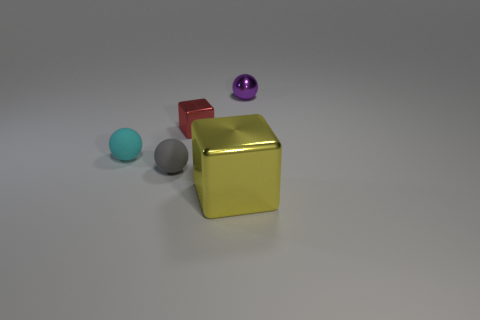Does the purple metal ball have the same size as the gray sphere?
Provide a succinct answer. Yes. There is a red metallic object; does it have the same size as the cyan rubber ball that is to the left of the gray thing?
Your answer should be very brief. Yes. The metallic thing that is behind the big cube and in front of the tiny metallic ball is what color?
Provide a short and direct response. Red. Are there more red objects that are left of the red shiny cube than gray rubber balls behind the small metal ball?
Ensure brevity in your answer.  No. What size is the purple sphere that is the same material as the big yellow thing?
Your answer should be compact. Small. What number of large yellow blocks are behind the small matte object left of the small gray ball?
Offer a terse response. 0. Is there a tiny gray rubber thing that has the same shape as the big thing?
Your response must be concise. No. The tiny shiny object that is in front of the small object behind the red metal cube is what color?
Offer a terse response. Red. Are there more large shiny objects than rubber things?
Offer a very short reply. No. How many other objects are the same size as the gray thing?
Offer a very short reply. 3. 